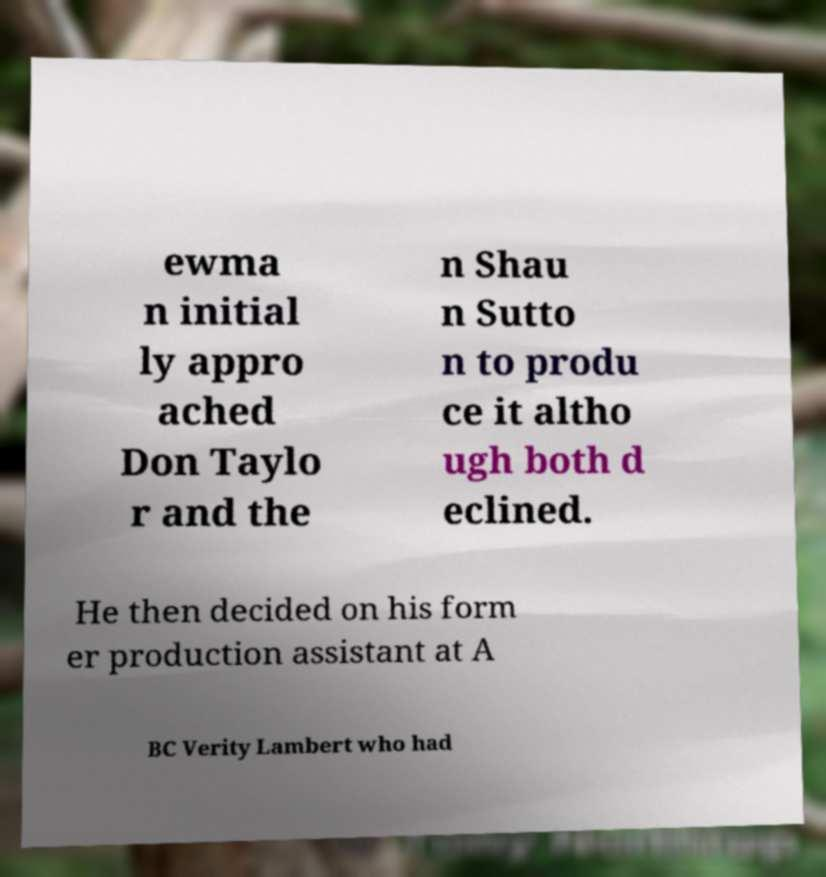I need the written content from this picture converted into text. Can you do that? ewma n initial ly appro ached Don Taylo r and the n Shau n Sutto n to produ ce it altho ugh both d eclined. He then decided on his form er production assistant at A BC Verity Lambert who had 